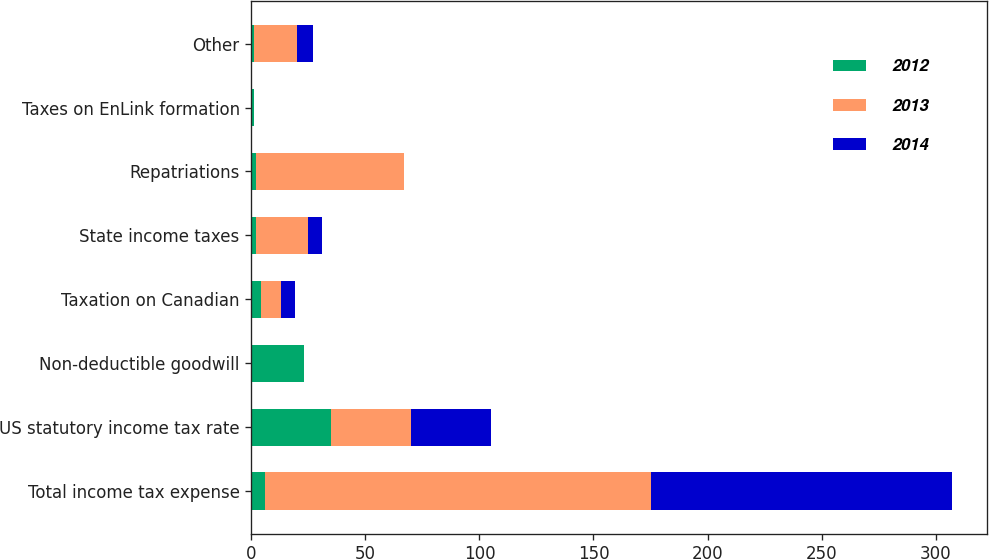Convert chart to OTSL. <chart><loc_0><loc_0><loc_500><loc_500><stacked_bar_chart><ecel><fcel>Total income tax expense<fcel>US statutory income tax rate<fcel>Non-deductible goodwill<fcel>Taxation on Canadian<fcel>State income taxes<fcel>Repatriations<fcel>Taxes on EnLink formation<fcel>Other<nl><fcel>2012<fcel>6<fcel>35<fcel>23<fcel>4<fcel>2<fcel>2<fcel>1<fcel>1<nl><fcel>2013<fcel>169<fcel>35<fcel>0<fcel>9<fcel>23<fcel>65<fcel>0<fcel>19<nl><fcel>2014<fcel>132<fcel>35<fcel>0<fcel>6<fcel>6<fcel>0<fcel>0<fcel>7<nl></chart> 